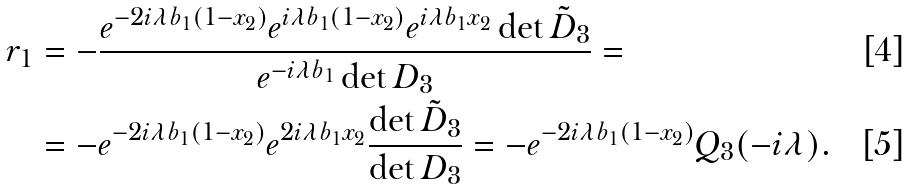<formula> <loc_0><loc_0><loc_500><loc_500>r _ { 1 } & = - \frac { e ^ { - 2 i \lambda b _ { 1 } ( 1 - x _ { 2 } ) } e ^ { i \lambda b _ { 1 } ( 1 - x _ { 2 } ) } e ^ { i \lambda b _ { 1 } x _ { 2 } } \det \tilde { D } _ { 3 } } { e ^ { - i \lambda b _ { 1 } } \det D _ { 3 } } = \\ & = - e ^ { - 2 i \lambda b _ { 1 } ( 1 - x _ { 2 } ) } e ^ { 2 i \lambda b _ { 1 } x _ { 2 } } \frac { \det \tilde { D } _ { 3 } } { \det D _ { 3 } } = - e ^ { - 2 i \lambda b _ { 1 } ( 1 - x _ { 2 } ) } Q _ { 3 } ( - i \lambda ) .</formula> 